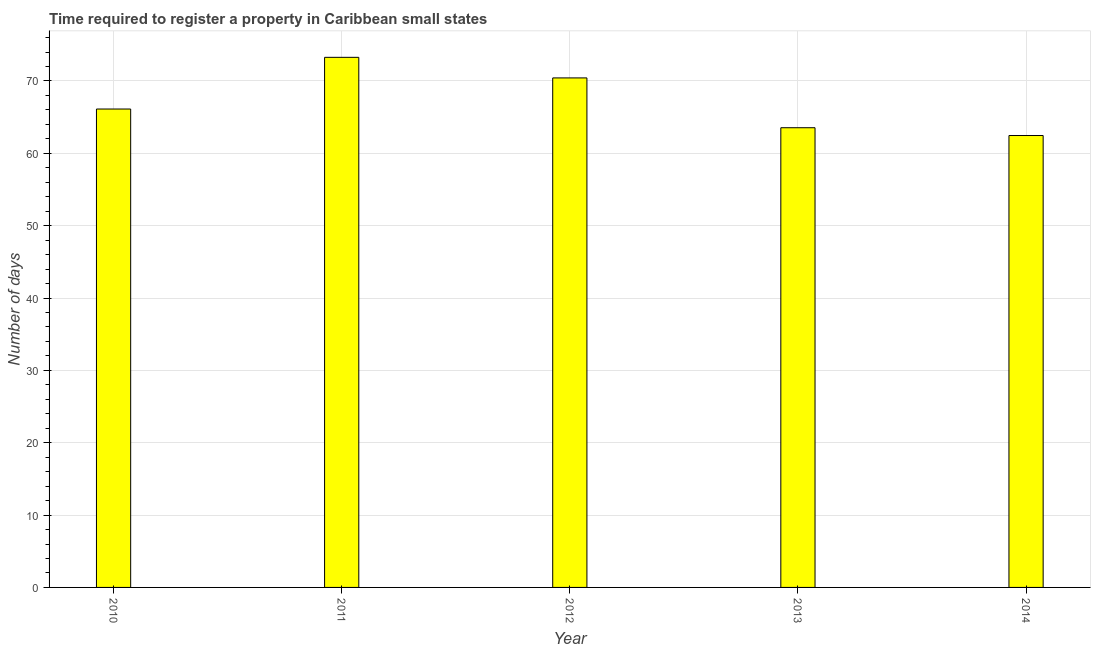Does the graph contain grids?
Offer a terse response. Yes. What is the title of the graph?
Your answer should be very brief. Time required to register a property in Caribbean small states. What is the label or title of the X-axis?
Keep it short and to the point. Year. What is the label or title of the Y-axis?
Your answer should be compact. Number of days. What is the number of days required to register property in 2010?
Your answer should be very brief. 66.12. Across all years, what is the maximum number of days required to register property?
Provide a succinct answer. 73.27. Across all years, what is the minimum number of days required to register property?
Give a very brief answer. 62.46. In which year was the number of days required to register property maximum?
Provide a short and direct response. 2011. What is the sum of the number of days required to register property?
Provide a succinct answer. 335.82. What is the difference between the number of days required to register property in 2012 and 2013?
Make the answer very short. 6.88. What is the average number of days required to register property per year?
Offer a terse response. 67.16. What is the median number of days required to register property?
Provide a short and direct response. 66.12. In how many years, is the number of days required to register property greater than 66 days?
Offer a terse response. 3. What is the ratio of the number of days required to register property in 2010 to that in 2014?
Keep it short and to the point. 1.06. Is the number of days required to register property in 2012 less than that in 2013?
Give a very brief answer. No. What is the difference between the highest and the second highest number of days required to register property?
Your answer should be compact. 2.85. What is the difference between the highest and the lowest number of days required to register property?
Your answer should be very brief. 10.81. Are all the bars in the graph horizontal?
Give a very brief answer. No. How many years are there in the graph?
Offer a terse response. 5. What is the Number of days in 2010?
Offer a very short reply. 66.12. What is the Number of days in 2011?
Your answer should be very brief. 73.27. What is the Number of days of 2012?
Provide a short and direct response. 70.42. What is the Number of days of 2013?
Provide a short and direct response. 63.54. What is the Number of days of 2014?
Ensure brevity in your answer.  62.46. What is the difference between the Number of days in 2010 and 2011?
Offer a terse response. -7.14. What is the difference between the Number of days in 2010 and 2012?
Your response must be concise. -4.3. What is the difference between the Number of days in 2010 and 2013?
Give a very brief answer. 2.59. What is the difference between the Number of days in 2010 and 2014?
Your answer should be very brief. 3.66. What is the difference between the Number of days in 2011 and 2012?
Provide a short and direct response. 2.85. What is the difference between the Number of days in 2011 and 2013?
Offer a terse response. 9.73. What is the difference between the Number of days in 2011 and 2014?
Provide a succinct answer. 10.81. What is the difference between the Number of days in 2012 and 2013?
Your answer should be very brief. 6.88. What is the difference between the Number of days in 2012 and 2014?
Keep it short and to the point. 7.96. What is the difference between the Number of days in 2013 and 2014?
Your answer should be very brief. 1.08. What is the ratio of the Number of days in 2010 to that in 2011?
Offer a very short reply. 0.9. What is the ratio of the Number of days in 2010 to that in 2012?
Your response must be concise. 0.94. What is the ratio of the Number of days in 2010 to that in 2013?
Give a very brief answer. 1.04. What is the ratio of the Number of days in 2010 to that in 2014?
Your answer should be very brief. 1.06. What is the ratio of the Number of days in 2011 to that in 2013?
Keep it short and to the point. 1.15. What is the ratio of the Number of days in 2011 to that in 2014?
Give a very brief answer. 1.17. What is the ratio of the Number of days in 2012 to that in 2013?
Make the answer very short. 1.11. What is the ratio of the Number of days in 2012 to that in 2014?
Your answer should be very brief. 1.13. 